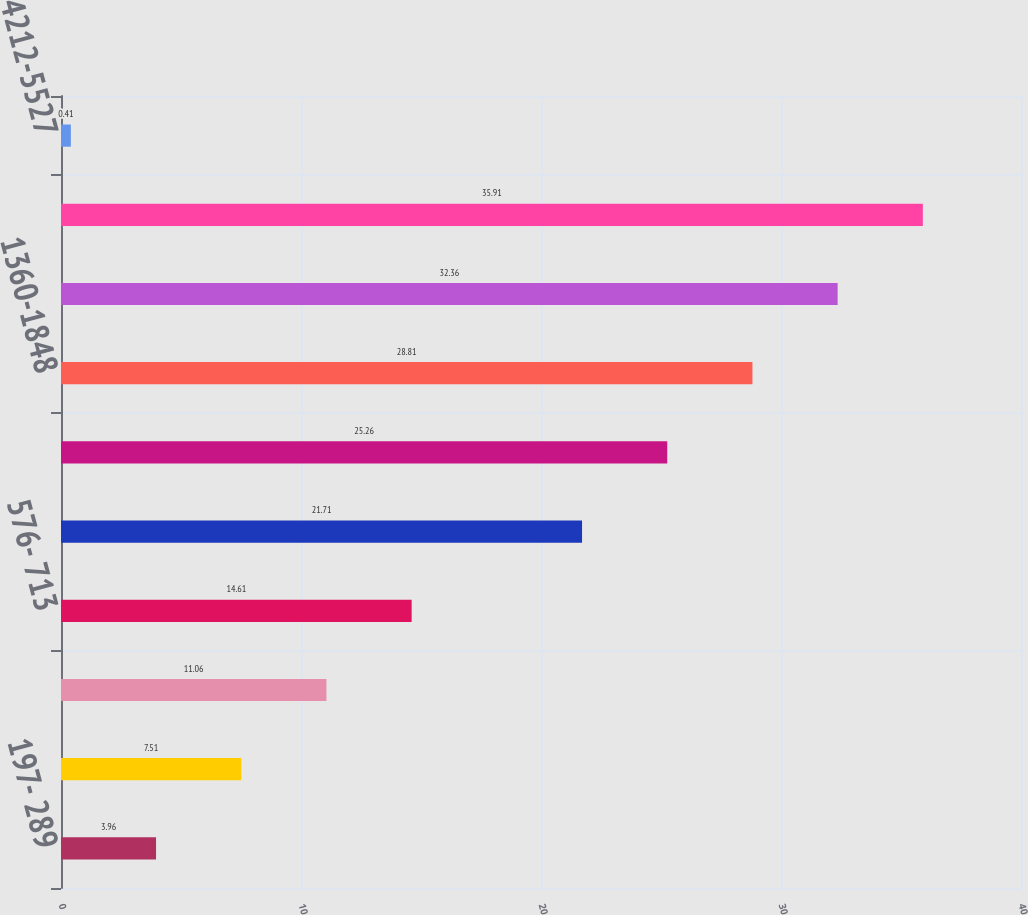Convert chart to OTSL. <chart><loc_0><loc_0><loc_500><loc_500><bar_chart><fcel>197- 289<fcel>294- 384<fcel>388- 575<fcel>576- 713<fcel>715-1018<fcel>1042-1331<fcel>1360-1848<fcel>1856-2773<fcel>2815-4157<fcel>4212-5527<nl><fcel>3.96<fcel>7.51<fcel>11.06<fcel>14.61<fcel>21.71<fcel>25.26<fcel>28.81<fcel>32.36<fcel>35.91<fcel>0.41<nl></chart> 